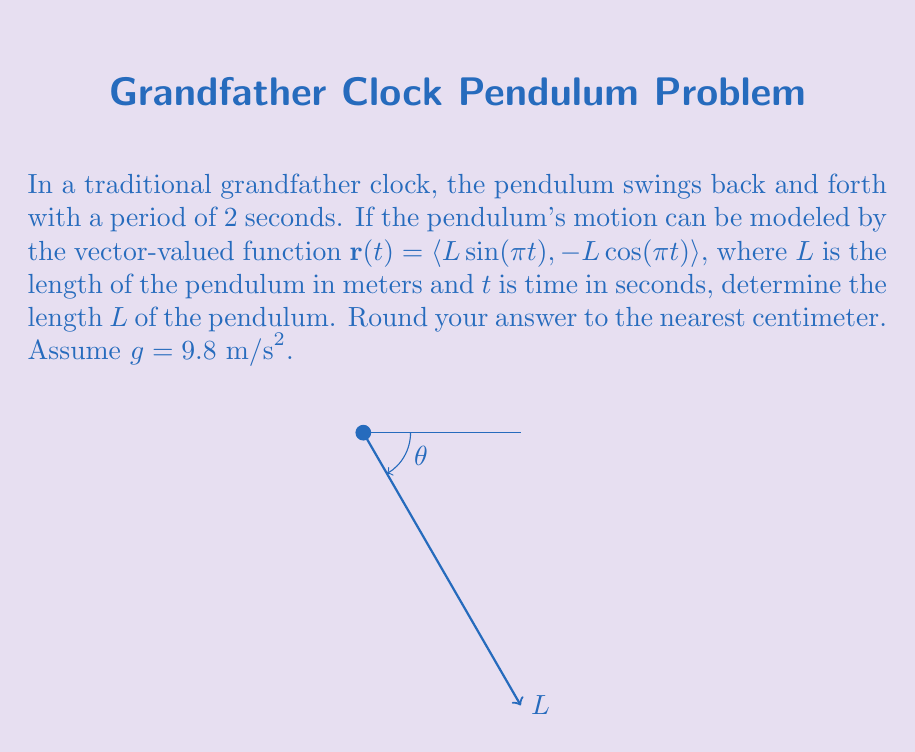Show me your answer to this math problem. Let's approach this step-by-step:

1) The period of a simple pendulum is given by the formula:

   $$T = 2\pi\sqrt{\frac{L}{g}}$$

   where $T$ is the period, $L$ is the length of the pendulum, and $g$ is the acceleration due to gravity.

2) We're given that the period is 2 seconds, so:

   $$2 = 2\pi\sqrt{\frac{L}{9.8}}$$

3) Square both sides:

   $$4 = 4\pi^2\frac{L}{9.8}$$

4) Multiply both sides by 9.8:

   $$39.2 = 4\pi^2L$$

5) Divide both sides by $4\pi^2$:

   $$L = \frac{39.2}{4\pi^2}$$

6) Calculate this value:

   $$L \approx 0.9936 \text{ meters}$$

7) Converting to centimeters and rounding to the nearest centimeter:

   $$L \approx 99 \text{ cm}$$
Answer: $99 \text{ cm}$ 